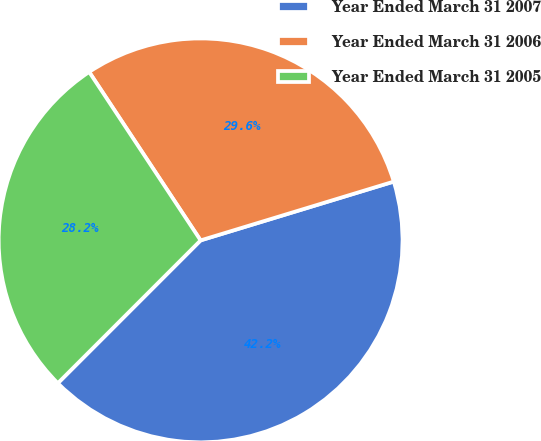<chart> <loc_0><loc_0><loc_500><loc_500><pie_chart><fcel>Year Ended March 31 2007<fcel>Year Ended March 31 2006<fcel>Year Ended March 31 2005<nl><fcel>42.2%<fcel>29.6%<fcel>28.2%<nl></chart> 